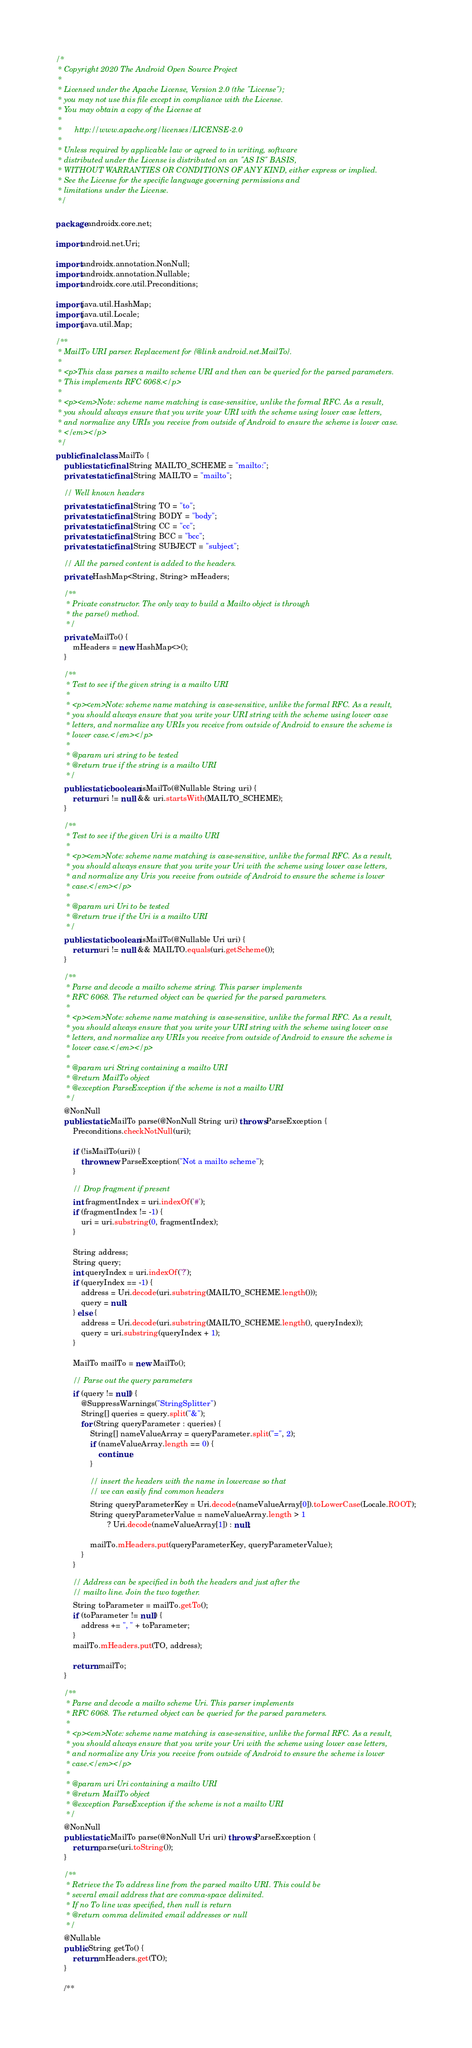<code> <loc_0><loc_0><loc_500><loc_500><_Java_>/*
 * Copyright 2020 The Android Open Source Project
 *
 * Licensed under the Apache License, Version 2.0 (the "License");
 * you may not use this file except in compliance with the License.
 * You may obtain a copy of the License at
 *
 *      http://www.apache.org/licenses/LICENSE-2.0
 *
 * Unless required by applicable law or agreed to in writing, software
 * distributed under the License is distributed on an "AS IS" BASIS,
 * WITHOUT WARRANTIES OR CONDITIONS OF ANY KIND, either express or implied.
 * See the License for the specific language governing permissions and
 * limitations under the License.
 */

package androidx.core.net;

import android.net.Uri;

import androidx.annotation.NonNull;
import androidx.annotation.Nullable;
import androidx.core.util.Preconditions;

import java.util.HashMap;
import java.util.Locale;
import java.util.Map;

/**
 * MailTo URI parser. Replacement for {@link android.net.MailTo}.
 *
 * <p>This class parses a mailto scheme URI and then can be queried for the parsed parameters.
 * This implements RFC 6068.</p>
 *
 * <p><em>Note: scheme name matching is case-sensitive, unlike the formal RFC. As a result,
 * you should always ensure that you write your URI with the scheme using lower case letters,
 * and normalize any URIs you receive from outside of Android to ensure the scheme is lower case.
 * </em></p>
 */
public final class MailTo {
    public static final String MAILTO_SCHEME = "mailto:";
    private static final String MAILTO = "mailto";

    // Well known headers
    private static final String TO = "to";
    private static final String BODY = "body";
    private static final String CC = "cc";
    private static final String BCC = "bcc";
    private static final String SUBJECT = "subject";

    // All the parsed content is added to the headers.
    private HashMap<String, String> mHeaders;

    /**
     * Private constructor. The only way to build a Mailto object is through
     * the parse() method.
     */
    private MailTo() {
        mHeaders = new HashMap<>();
    }

    /**
     * Test to see if the given string is a mailto URI
     *
     * <p><em>Note: scheme name matching is case-sensitive, unlike the formal RFC. As a result,
     * you should always ensure that you write your URI string with the scheme using lower case
     * letters, and normalize any URIs you receive from outside of Android to ensure the scheme is
     * lower case.</em></p>
     *
     * @param uri string to be tested
     * @return true if the string is a mailto URI
     */
    public static boolean isMailTo(@Nullable String uri) {
        return uri != null && uri.startsWith(MAILTO_SCHEME);
    }

    /**
     * Test to see if the given Uri is a mailto URI
     *
     * <p><em>Note: scheme name matching is case-sensitive, unlike the formal RFC. As a result,
     * you should always ensure that you write your Uri with the scheme using lower case letters,
     * and normalize any Uris you receive from outside of Android to ensure the scheme is lower
     * case.</em></p>
     *
     * @param uri Uri to be tested
     * @return true if the Uri is a mailto URI
     */
    public static boolean isMailTo(@Nullable Uri uri) {
        return uri != null && MAILTO.equals(uri.getScheme());
    }

    /**
     * Parse and decode a mailto scheme string. This parser implements
     * RFC 6068. The returned object can be queried for the parsed parameters.
     *
     * <p><em>Note: scheme name matching is case-sensitive, unlike the formal RFC. As a result,
     * you should always ensure that you write your URI string with the scheme using lower case
     * letters, and normalize any URIs you receive from outside of Android to ensure the scheme is
     * lower case.</em></p>
     *
     * @param uri String containing a mailto URI
     * @return MailTo object
     * @exception ParseException if the scheme is not a mailto URI
     */
    @NonNull
    public static MailTo parse(@NonNull String uri) throws ParseException {
        Preconditions.checkNotNull(uri);

        if (!isMailTo(uri)) {
            throw new ParseException("Not a mailto scheme");
        }

        // Drop fragment if present
        int fragmentIndex = uri.indexOf('#');
        if (fragmentIndex != -1) {
            uri = uri.substring(0, fragmentIndex);
        }

        String address;
        String query;
        int queryIndex = uri.indexOf('?');
        if (queryIndex == -1) {
            address = Uri.decode(uri.substring(MAILTO_SCHEME.length()));
            query = null;
        } else {
            address = Uri.decode(uri.substring(MAILTO_SCHEME.length(), queryIndex));
            query = uri.substring(queryIndex + 1);
        }

        MailTo mailTo = new MailTo();

        // Parse out the query parameters
        if (query != null) {
            @SuppressWarnings("StringSplitter")
            String[] queries = query.split("&");
            for (String queryParameter : queries) {
                String[] nameValueArray = queryParameter.split("=", 2);
                if (nameValueArray.length == 0) {
                    continue;
                }

                // insert the headers with the name in lowercase so that
                // we can easily find common headers
                String queryParameterKey = Uri.decode(nameValueArray[0]).toLowerCase(Locale.ROOT);
                String queryParameterValue = nameValueArray.length > 1
                        ? Uri.decode(nameValueArray[1]) : null;

                mailTo.mHeaders.put(queryParameterKey, queryParameterValue);
            }
        }

        // Address can be specified in both the headers and just after the
        // mailto line. Join the two together.
        String toParameter = mailTo.getTo();
        if (toParameter != null) {
            address += ", " + toParameter;
        }
        mailTo.mHeaders.put(TO, address);

        return mailTo;
    }

    /**
     * Parse and decode a mailto scheme Uri. This parser implements
     * RFC 6068. The returned object can be queried for the parsed parameters.
     *
     * <p><em>Note: scheme name matching is case-sensitive, unlike the formal RFC. As a result,
     * you should always ensure that you write your Uri with the scheme using lower case letters,
     * and normalize any Uris you receive from outside of Android to ensure the scheme is lower
     * case.</em></p>
     *
     * @param uri Uri containing a mailto URI
     * @return MailTo object
     * @exception ParseException if the scheme is not a mailto URI
     */
    @NonNull
    public static MailTo parse(@NonNull Uri uri) throws ParseException {
        return parse(uri.toString());
    }

    /**
     * Retrieve the To address line from the parsed mailto URI. This could be
     * several email address that are comma-space delimited.
     * If no To line was specified, then null is return
     * @return comma delimited email addresses or null
     */
    @Nullable
    public String getTo() {
        return mHeaders.get(TO);
    }

    /**</code> 